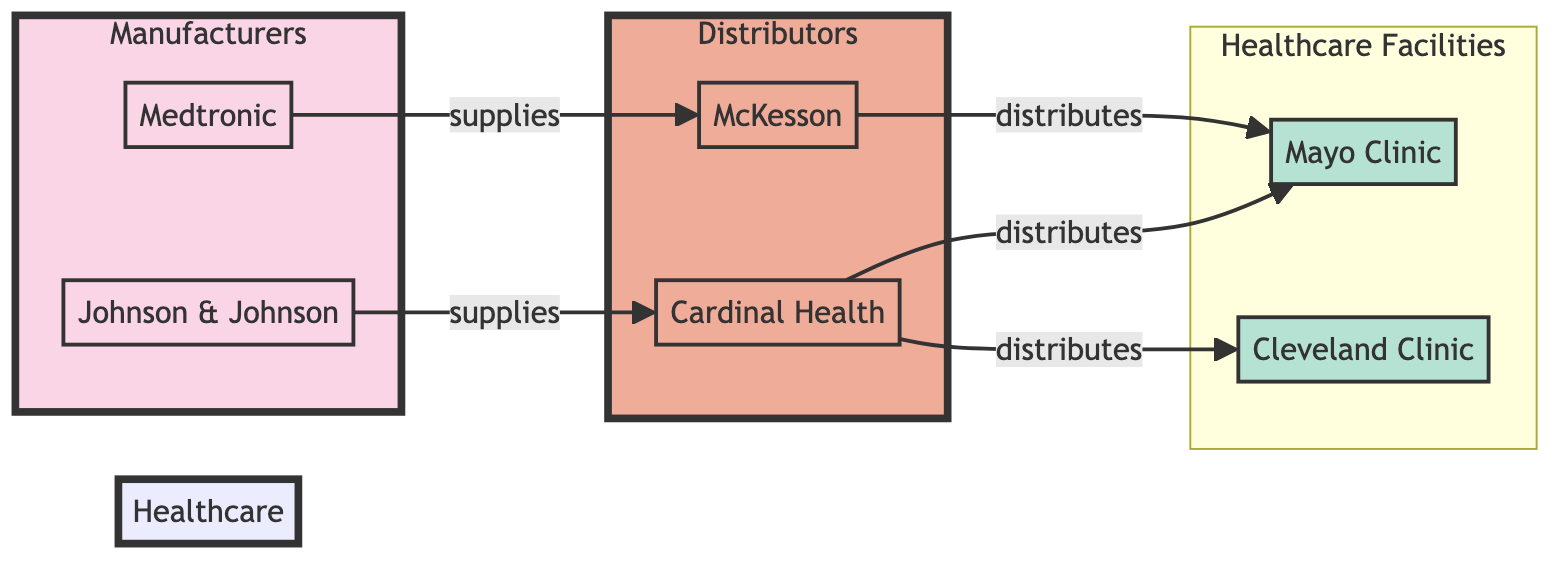What are the names of the manufacturers in this diagram? The diagram includes two manufacturers: Johnson & Johnson and Medtronic, which are labeled as "Manufacturer" nodes.
Answer: Johnson & Johnson, Medtronic How many healthcare facilities are represented in the diagram? The diagram shows two healthcare facilities: Mayo Clinic and Cleveland Clinic, which are categorized as "Healthcare Facility" nodes. Counting these nodes indicates there are two healthcare facilities.
Answer: 2 Which distributor supplies the Mayo Clinic? The Mayo Clinic is connected to both Cardinal Health and McKesson through a "distributes" relationship. Therefore, both distributors supply the Mayo Clinic.
Answer: Cardinal Health, McKesson What is the relationship between Johnson & Johnson and Cardinal Health? The diagram indicates that Johnson & Johnson has a "supplies" relationship with Cardinal Health, meaning that Johnson & Johnson provides equipment to this distributor.
Answer: supplies Which healthcare facility receives distributions from both distributors? The diagram shows that the Mayo Clinic receives distributions from both Cardinal Health and McKesson, while Cleveland Clinic only receives from Cardinal Health. Therefore, the answer is the Mayo Clinic.
Answer: Mayo Clinic How many total connections (edges) are there in the diagram? By examining the links, we see that there are five connections: Johnson & Johnson to Cardinal Health, Medtronic to McKesson, Cardinal Health to Mayo Clinic, Cardinal Health to Cleveland Clinic, and McKesson to Mayo Clinic. Counting these gives us a total of five connections.
Answer: 5 Which distributor is linked to Medtronic? The diagram shows that Medtronic is linked to the distributor McKesson, indicating that Medtronic supplies this distributor.
Answer: McKesson Does Cardinal Health distribute to the Cleveland Clinic? Checking the links, Cardinal Health is shown to distribute to both the Mayo Clinic and the Cleveland Clinic, thus it does distribute to the Cleveland Clinic as well.
Answer: Yes 